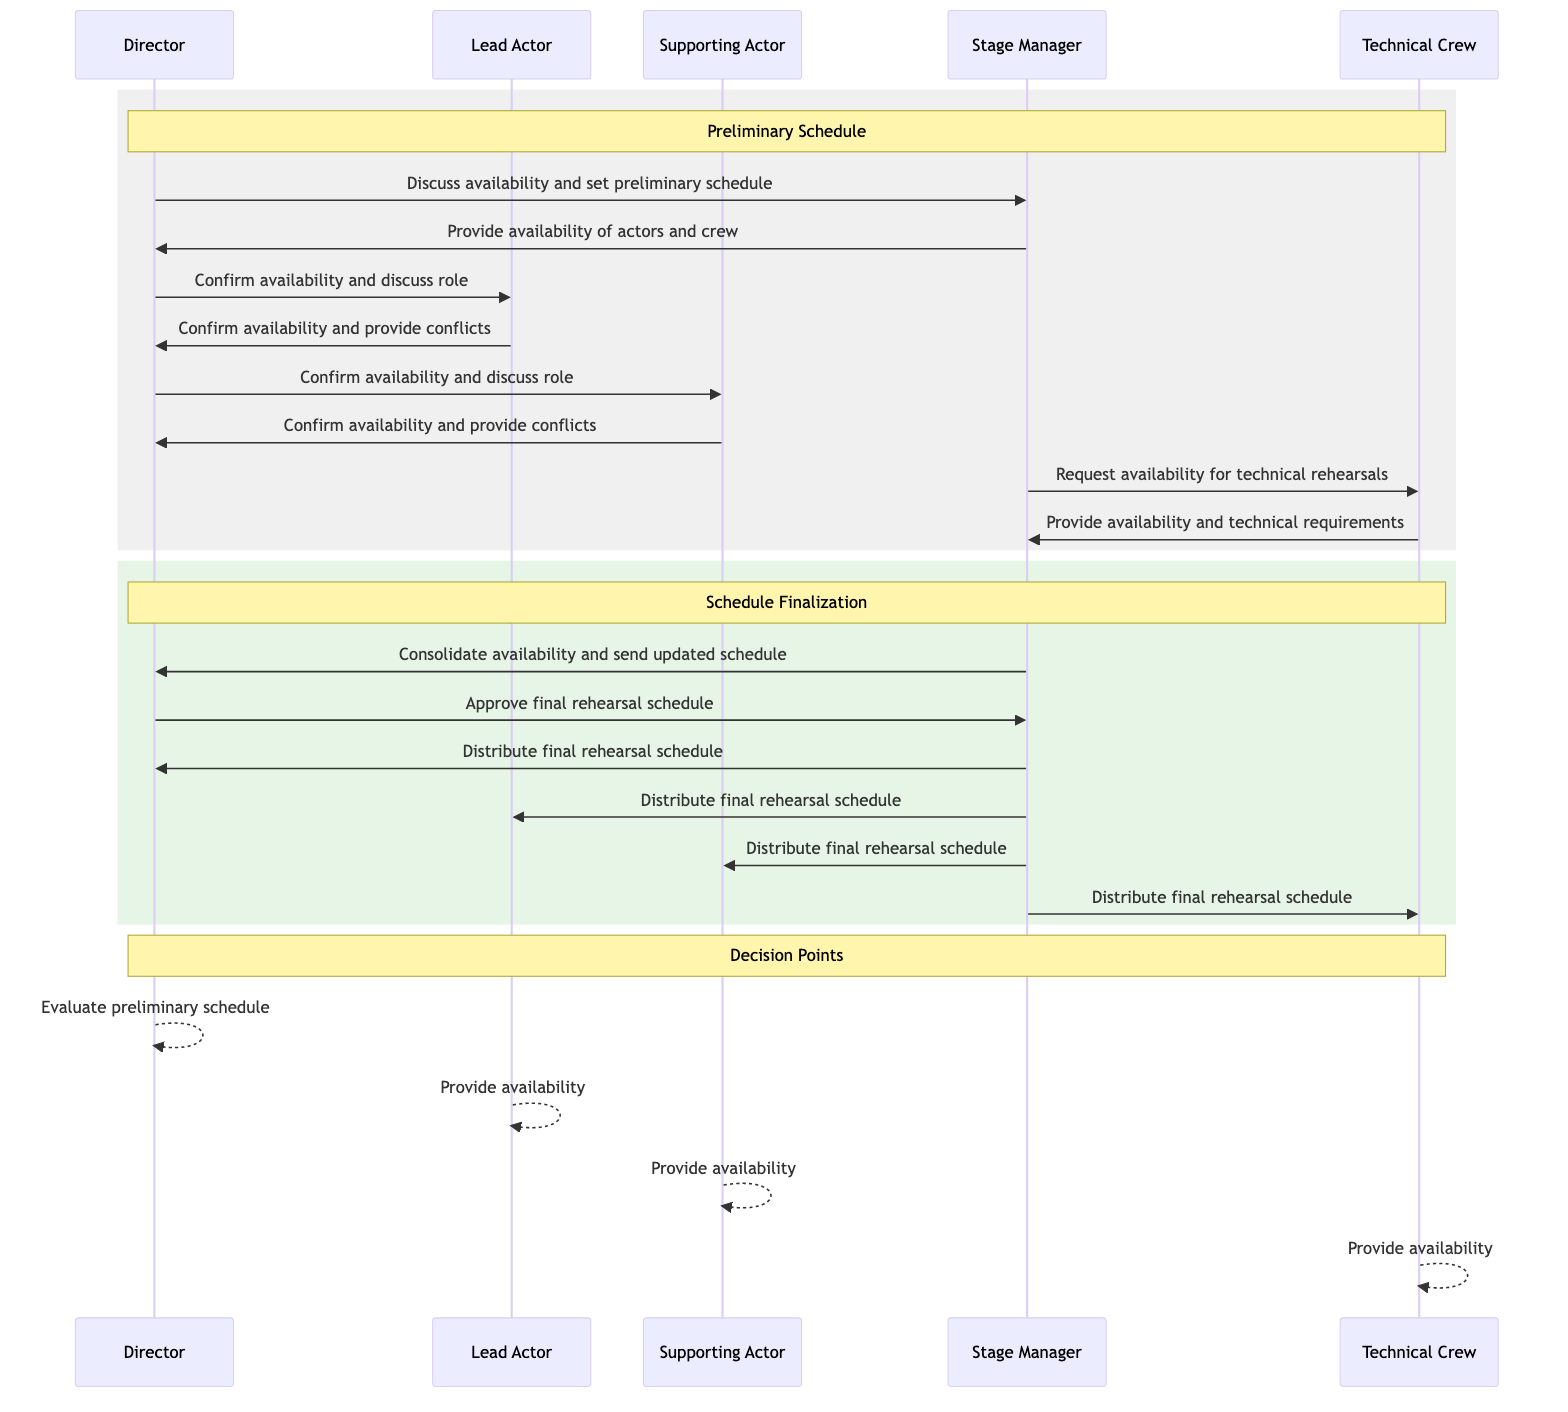What is the first message sent in the diagram? The first message is sent from the Director to the Stage Manager, discussing availability and setting a preliminary rehearsal schedule.
Answer: Discuss availability and set preliminary rehearsal schedule How many actors are directly involved in the rehearsal schedule coordination? The actors directly involved are the Director, Lead Actor, Supporting Actor, and Stage Manager. This totals four actors.
Answer: Four What is the last action taken in the diagram? The last action is the Stage Manager distributing the final rehearsal schedule to all participants.
Answer: Distribute final rehearsal schedule What does the Director evaluate in the decision points? The Director evaluates the preliminary schedule as part of the decision points.
Answer: Preliminary schedule Which actor confirms their availability last in the flow? The Supporting Actor confirms their availability last in the flow after the Lead Actor.
Answer: Supporting Actor What happens after the Technical Crew sends their availability? After the Technical Crew provides availability and technical requirements, the Stage Manager consolidates all availability and sends an updated schedule to the Director.
Answer: Consolidate availability and send updated schedule How many decision points are present in the diagram? There are three decision points present in the diagram that involve evaluating and providing availability.
Answer: Three What is the primary role of the Stage Manager in this sequence? The primary role of the Stage Manager is to coordinate the availability of actors and crew and manage the communication between the Director and the Technical Crew.
Answer: Coordinate availability Who is involved in confirming availability besides the Director? The Lead Actor and Supporting Actor are both involved in confirming their availability alongside the Director.
Answer: Lead Actor and Supporting Actor 